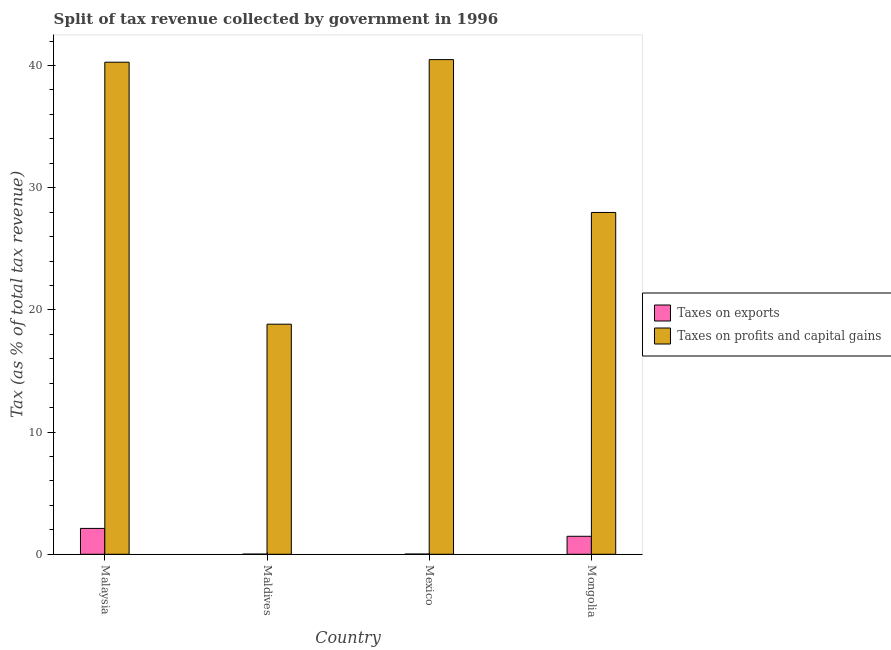How many different coloured bars are there?
Offer a very short reply. 2. How many groups of bars are there?
Your response must be concise. 4. Are the number of bars on each tick of the X-axis equal?
Offer a very short reply. Yes. How many bars are there on the 3rd tick from the left?
Provide a short and direct response. 2. How many bars are there on the 3rd tick from the right?
Your response must be concise. 2. What is the label of the 2nd group of bars from the left?
Make the answer very short. Maldives. What is the percentage of revenue obtained from taxes on exports in Mongolia?
Offer a very short reply. 1.47. Across all countries, what is the maximum percentage of revenue obtained from taxes on profits and capital gains?
Ensure brevity in your answer.  40.48. Across all countries, what is the minimum percentage of revenue obtained from taxes on exports?
Offer a very short reply. 0.01. In which country was the percentage of revenue obtained from taxes on exports maximum?
Make the answer very short. Malaysia. In which country was the percentage of revenue obtained from taxes on exports minimum?
Give a very brief answer. Maldives. What is the total percentage of revenue obtained from taxes on exports in the graph?
Your answer should be very brief. 3.62. What is the difference between the percentage of revenue obtained from taxes on exports in Maldives and that in Mexico?
Your answer should be very brief. -0. What is the difference between the percentage of revenue obtained from taxes on exports in Malaysia and the percentage of revenue obtained from taxes on profits and capital gains in Mexico?
Your response must be concise. -38.37. What is the average percentage of revenue obtained from taxes on exports per country?
Your answer should be very brief. 0.91. What is the difference between the percentage of revenue obtained from taxes on profits and capital gains and percentage of revenue obtained from taxes on exports in Mexico?
Provide a succinct answer. 40.46. In how many countries, is the percentage of revenue obtained from taxes on exports greater than 38 %?
Your answer should be very brief. 0. What is the ratio of the percentage of revenue obtained from taxes on profits and capital gains in Maldives to that in Mongolia?
Your answer should be very brief. 0.67. What is the difference between the highest and the second highest percentage of revenue obtained from taxes on profits and capital gains?
Provide a short and direct response. 0.21. What is the difference between the highest and the lowest percentage of revenue obtained from taxes on exports?
Offer a terse response. 2.1. What does the 2nd bar from the left in Mexico represents?
Give a very brief answer. Taxes on profits and capital gains. What does the 2nd bar from the right in Malaysia represents?
Your answer should be compact. Taxes on exports. How many bars are there?
Provide a succinct answer. 8. Does the graph contain grids?
Offer a very short reply. No. Where does the legend appear in the graph?
Provide a short and direct response. Center right. How many legend labels are there?
Keep it short and to the point. 2. What is the title of the graph?
Make the answer very short. Split of tax revenue collected by government in 1996. What is the label or title of the Y-axis?
Offer a terse response. Tax (as % of total tax revenue). What is the Tax (as % of total tax revenue) in Taxes on exports in Malaysia?
Your response must be concise. 2.12. What is the Tax (as % of total tax revenue) in Taxes on profits and capital gains in Malaysia?
Your response must be concise. 40.27. What is the Tax (as % of total tax revenue) in Taxes on exports in Maldives?
Provide a succinct answer. 0.01. What is the Tax (as % of total tax revenue) of Taxes on profits and capital gains in Maldives?
Give a very brief answer. 18.83. What is the Tax (as % of total tax revenue) of Taxes on exports in Mexico?
Ensure brevity in your answer.  0.02. What is the Tax (as % of total tax revenue) in Taxes on profits and capital gains in Mexico?
Keep it short and to the point. 40.48. What is the Tax (as % of total tax revenue) in Taxes on exports in Mongolia?
Offer a very short reply. 1.47. What is the Tax (as % of total tax revenue) in Taxes on profits and capital gains in Mongolia?
Your answer should be very brief. 27.97. Across all countries, what is the maximum Tax (as % of total tax revenue) of Taxes on exports?
Your answer should be very brief. 2.12. Across all countries, what is the maximum Tax (as % of total tax revenue) of Taxes on profits and capital gains?
Provide a short and direct response. 40.48. Across all countries, what is the minimum Tax (as % of total tax revenue) of Taxes on exports?
Keep it short and to the point. 0.01. Across all countries, what is the minimum Tax (as % of total tax revenue) in Taxes on profits and capital gains?
Your response must be concise. 18.83. What is the total Tax (as % of total tax revenue) of Taxes on exports in the graph?
Your response must be concise. 3.62. What is the total Tax (as % of total tax revenue) of Taxes on profits and capital gains in the graph?
Your answer should be very brief. 127.56. What is the difference between the Tax (as % of total tax revenue) of Taxes on exports in Malaysia and that in Maldives?
Offer a terse response. 2.1. What is the difference between the Tax (as % of total tax revenue) of Taxes on profits and capital gains in Malaysia and that in Maldives?
Your response must be concise. 21.44. What is the difference between the Tax (as % of total tax revenue) of Taxes on exports in Malaysia and that in Mexico?
Provide a succinct answer. 2.1. What is the difference between the Tax (as % of total tax revenue) of Taxes on profits and capital gains in Malaysia and that in Mexico?
Your answer should be compact. -0.21. What is the difference between the Tax (as % of total tax revenue) in Taxes on exports in Malaysia and that in Mongolia?
Give a very brief answer. 0.65. What is the difference between the Tax (as % of total tax revenue) in Taxes on profits and capital gains in Malaysia and that in Mongolia?
Your answer should be compact. 12.3. What is the difference between the Tax (as % of total tax revenue) of Taxes on exports in Maldives and that in Mexico?
Make the answer very short. -0. What is the difference between the Tax (as % of total tax revenue) of Taxes on profits and capital gains in Maldives and that in Mexico?
Offer a very short reply. -21.65. What is the difference between the Tax (as % of total tax revenue) in Taxes on exports in Maldives and that in Mongolia?
Offer a very short reply. -1.46. What is the difference between the Tax (as % of total tax revenue) of Taxes on profits and capital gains in Maldives and that in Mongolia?
Your answer should be compact. -9.14. What is the difference between the Tax (as % of total tax revenue) in Taxes on exports in Mexico and that in Mongolia?
Your answer should be compact. -1.45. What is the difference between the Tax (as % of total tax revenue) of Taxes on profits and capital gains in Mexico and that in Mongolia?
Your answer should be compact. 12.51. What is the difference between the Tax (as % of total tax revenue) of Taxes on exports in Malaysia and the Tax (as % of total tax revenue) of Taxes on profits and capital gains in Maldives?
Provide a succinct answer. -16.71. What is the difference between the Tax (as % of total tax revenue) of Taxes on exports in Malaysia and the Tax (as % of total tax revenue) of Taxes on profits and capital gains in Mexico?
Your response must be concise. -38.37. What is the difference between the Tax (as % of total tax revenue) of Taxes on exports in Malaysia and the Tax (as % of total tax revenue) of Taxes on profits and capital gains in Mongolia?
Your answer should be very brief. -25.86. What is the difference between the Tax (as % of total tax revenue) in Taxes on exports in Maldives and the Tax (as % of total tax revenue) in Taxes on profits and capital gains in Mexico?
Ensure brevity in your answer.  -40.47. What is the difference between the Tax (as % of total tax revenue) of Taxes on exports in Maldives and the Tax (as % of total tax revenue) of Taxes on profits and capital gains in Mongolia?
Make the answer very short. -27.96. What is the difference between the Tax (as % of total tax revenue) in Taxes on exports in Mexico and the Tax (as % of total tax revenue) in Taxes on profits and capital gains in Mongolia?
Provide a succinct answer. -27.96. What is the average Tax (as % of total tax revenue) of Taxes on exports per country?
Keep it short and to the point. 0.91. What is the average Tax (as % of total tax revenue) in Taxes on profits and capital gains per country?
Provide a short and direct response. 31.89. What is the difference between the Tax (as % of total tax revenue) in Taxes on exports and Tax (as % of total tax revenue) in Taxes on profits and capital gains in Malaysia?
Make the answer very short. -38.15. What is the difference between the Tax (as % of total tax revenue) in Taxes on exports and Tax (as % of total tax revenue) in Taxes on profits and capital gains in Maldives?
Your answer should be compact. -18.82. What is the difference between the Tax (as % of total tax revenue) of Taxes on exports and Tax (as % of total tax revenue) of Taxes on profits and capital gains in Mexico?
Ensure brevity in your answer.  -40.46. What is the difference between the Tax (as % of total tax revenue) of Taxes on exports and Tax (as % of total tax revenue) of Taxes on profits and capital gains in Mongolia?
Make the answer very short. -26.5. What is the ratio of the Tax (as % of total tax revenue) in Taxes on exports in Malaysia to that in Maldives?
Your answer should be compact. 150.98. What is the ratio of the Tax (as % of total tax revenue) in Taxes on profits and capital gains in Malaysia to that in Maldives?
Your answer should be compact. 2.14. What is the ratio of the Tax (as % of total tax revenue) in Taxes on exports in Malaysia to that in Mexico?
Provide a short and direct response. 115.63. What is the ratio of the Tax (as % of total tax revenue) of Taxes on exports in Malaysia to that in Mongolia?
Your response must be concise. 1.44. What is the ratio of the Tax (as % of total tax revenue) of Taxes on profits and capital gains in Malaysia to that in Mongolia?
Your answer should be compact. 1.44. What is the ratio of the Tax (as % of total tax revenue) of Taxes on exports in Maldives to that in Mexico?
Provide a succinct answer. 0.77. What is the ratio of the Tax (as % of total tax revenue) in Taxes on profits and capital gains in Maldives to that in Mexico?
Your answer should be compact. 0.47. What is the ratio of the Tax (as % of total tax revenue) of Taxes on exports in Maldives to that in Mongolia?
Your answer should be compact. 0.01. What is the ratio of the Tax (as % of total tax revenue) of Taxes on profits and capital gains in Maldives to that in Mongolia?
Provide a short and direct response. 0.67. What is the ratio of the Tax (as % of total tax revenue) of Taxes on exports in Mexico to that in Mongolia?
Your response must be concise. 0.01. What is the ratio of the Tax (as % of total tax revenue) in Taxes on profits and capital gains in Mexico to that in Mongolia?
Your answer should be compact. 1.45. What is the difference between the highest and the second highest Tax (as % of total tax revenue) in Taxes on exports?
Make the answer very short. 0.65. What is the difference between the highest and the second highest Tax (as % of total tax revenue) in Taxes on profits and capital gains?
Your answer should be compact. 0.21. What is the difference between the highest and the lowest Tax (as % of total tax revenue) of Taxes on exports?
Give a very brief answer. 2.1. What is the difference between the highest and the lowest Tax (as % of total tax revenue) in Taxes on profits and capital gains?
Offer a terse response. 21.65. 